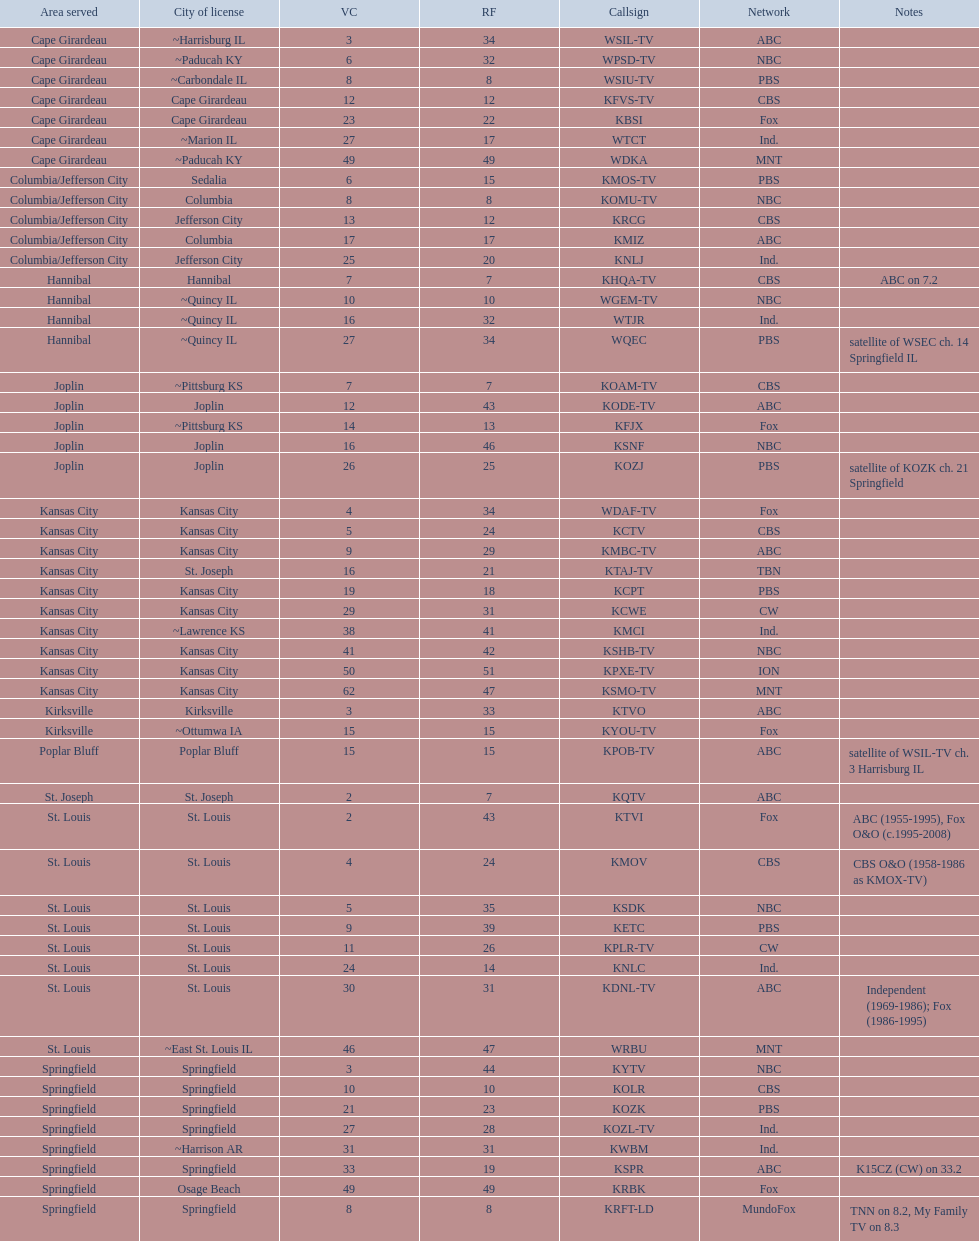What is the overall quantity of stations belonging to the cbs network? 7. 